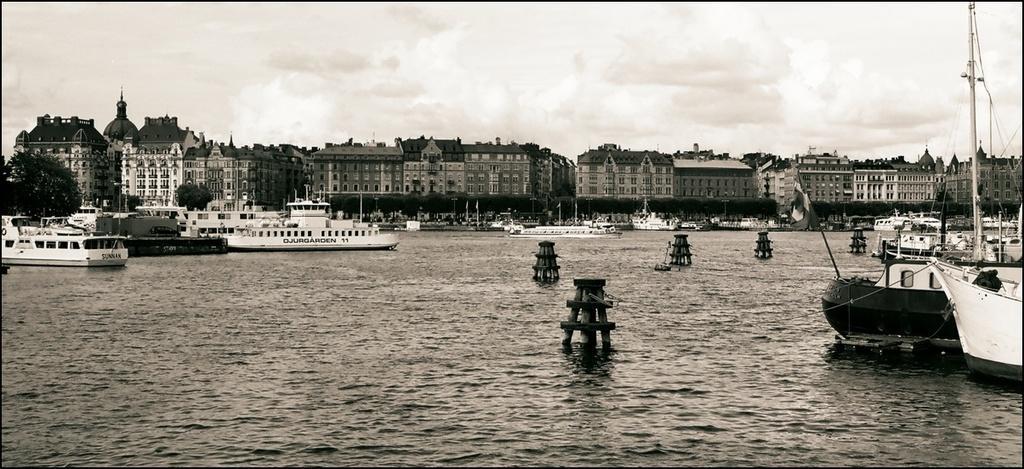Describe this image in one or two sentences. This is a black and white image. In this image we can see buildings, boats, trees. At the top of the image there is sky and clouds. At the bottom of the image there is water. 